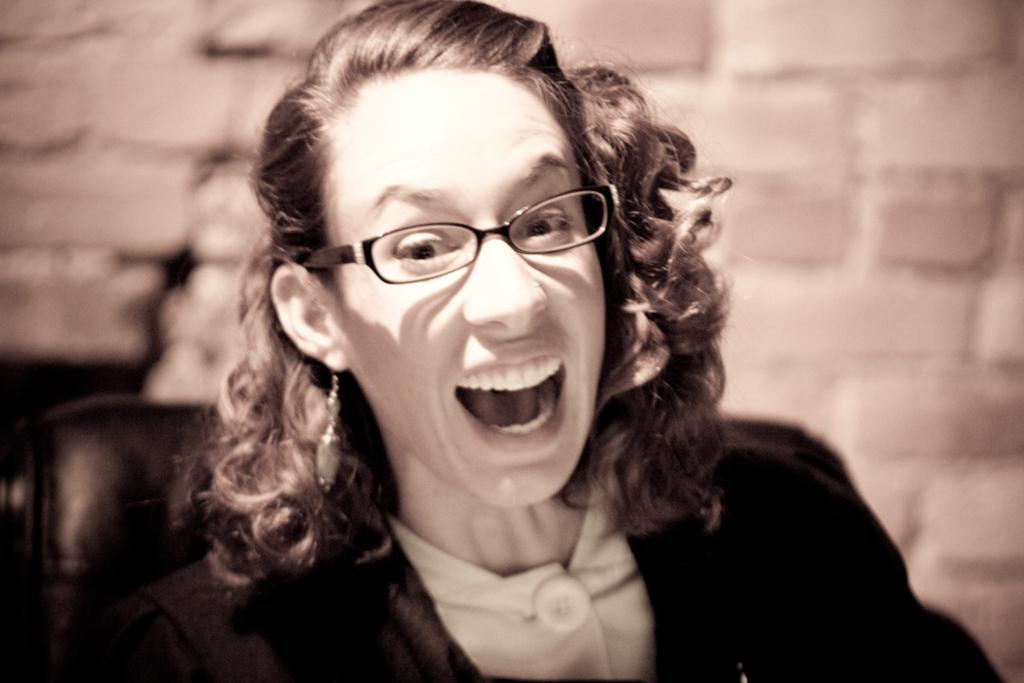Who is the main subject in the image? There is a woman in the image. What is the woman doing in the image? The woman is laughing. What accessories is the woman wearing in the image? The woman is wearing spectacles and a black coat. What is visible behind the woman in the image? There is a wall behind the woman. What type of shock can be seen affecting the woman in the image? There is no shock present in the image; the woman is laughing. Can you see any hooks or needles in the image? No, there are no hooks or needles present in the image. 